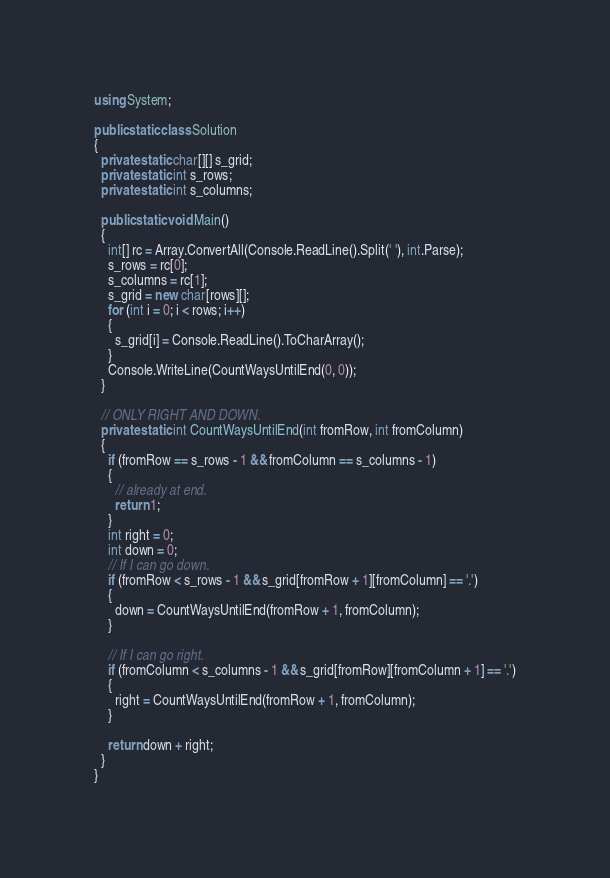<code> <loc_0><loc_0><loc_500><loc_500><_C#_>using System;

public static class Solution
{
  private static char[][] s_grid;
  private static int s_rows;
  private static int s_columns;

  public static void Main()
  {
    int[] rc = Array.ConvertAll(Console.ReadLine().Split(' '), int.Parse);
    s_rows = rc[0];
    s_columns = rc[1];
    s_grid = new char[rows][];
    for (int i = 0; i < rows; i++)
    {
      s_grid[i] = Console.ReadLine().ToCharArray();
    }
    Console.WriteLine(CountWaysUntilEnd(0, 0));
  }

  // ONLY RIGHT AND DOWN.
  private static int CountWaysUntilEnd(int fromRow, int fromColumn)
  {
    if (fromRow == s_rows - 1 && fromColumn == s_columns - 1)
    {
      // already at end.
      return 1;
    }
    int right = 0;
    int down = 0;
    // If I can go down.
    if (fromRow < s_rows - 1 && s_grid[fromRow + 1][fromColumn] == '.')
    {
      down = CountWaysUntilEnd(fromRow + 1, fromColumn);
    }

    // If I can go right.
    if (fromColumn < s_columns - 1 && s_grid[fromRow][fromColumn + 1] == '.')
    {
      right = CountWaysUntilEnd(fromRow + 1, fromColumn);
    }

    return down + right;
  }
}</code> 